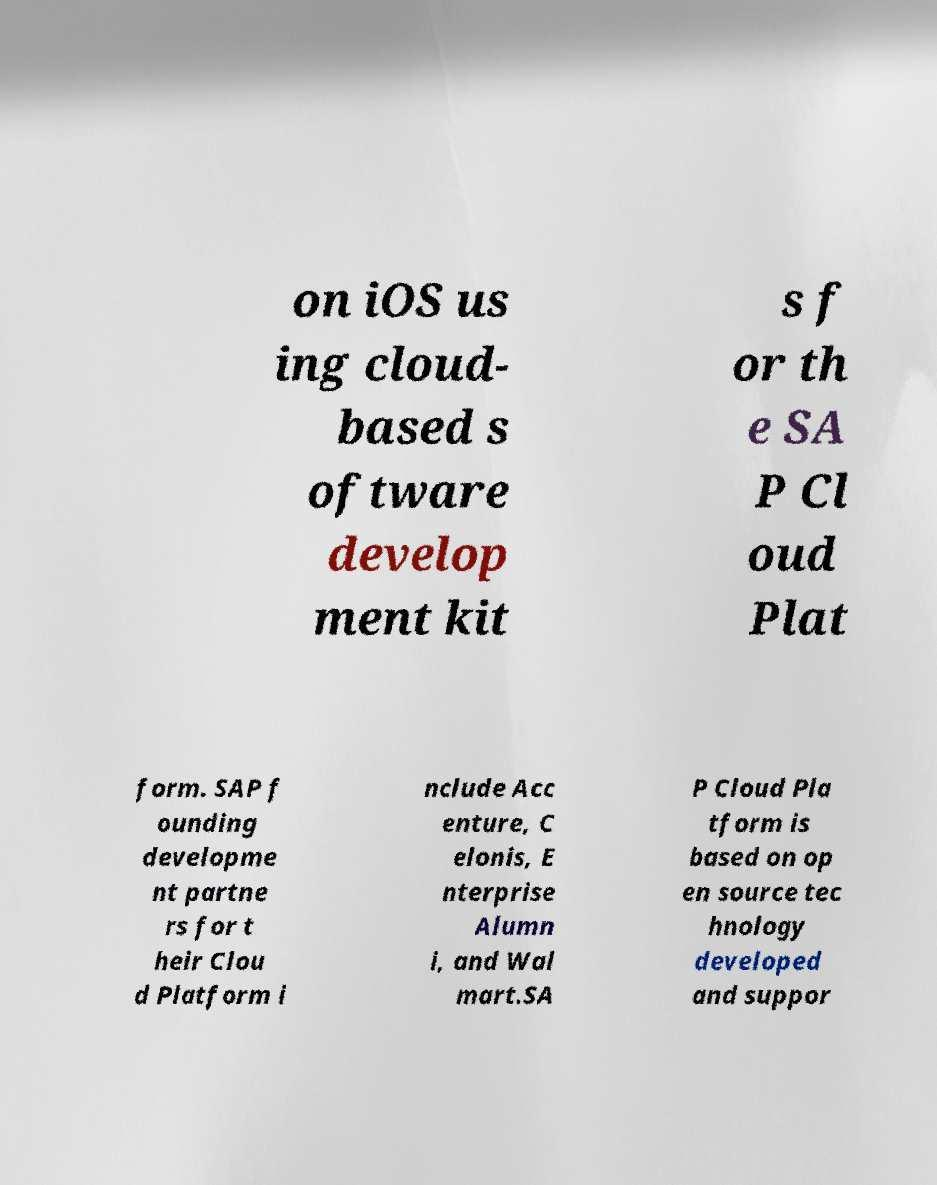Can you read and provide the text displayed in the image?This photo seems to have some interesting text. Can you extract and type it out for me? on iOS us ing cloud- based s oftware develop ment kit s f or th e SA P Cl oud Plat form. SAP f ounding developme nt partne rs for t heir Clou d Platform i nclude Acc enture, C elonis, E nterprise Alumn i, and Wal mart.SA P Cloud Pla tform is based on op en source tec hnology developed and suppor 